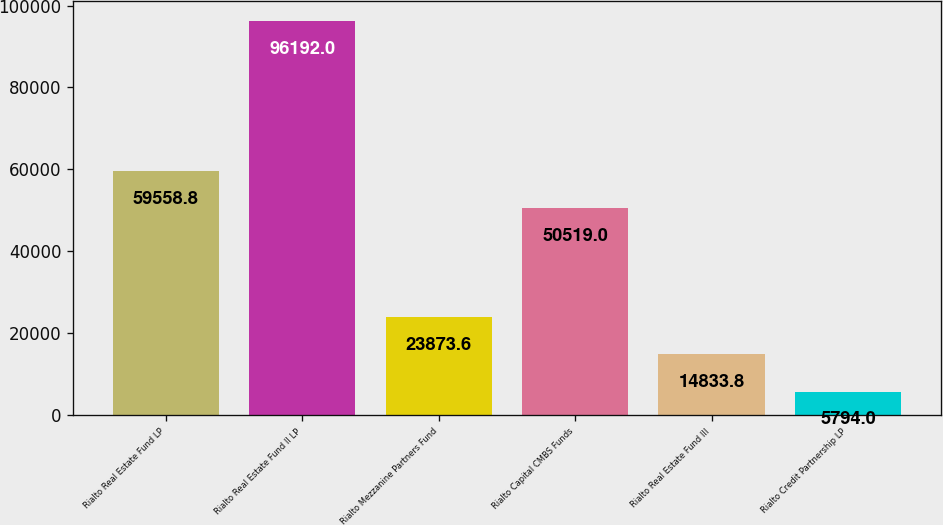Convert chart to OTSL. <chart><loc_0><loc_0><loc_500><loc_500><bar_chart><fcel>Rialto Real Estate Fund LP<fcel>Rialto Real Estate Fund II LP<fcel>Rialto Mezzanine Partners Fund<fcel>Rialto Capital CMBS Funds<fcel>Rialto Real Estate Fund III<fcel>Rialto Credit Partnership LP<nl><fcel>59558.8<fcel>96192<fcel>23873.6<fcel>50519<fcel>14833.8<fcel>5794<nl></chart> 